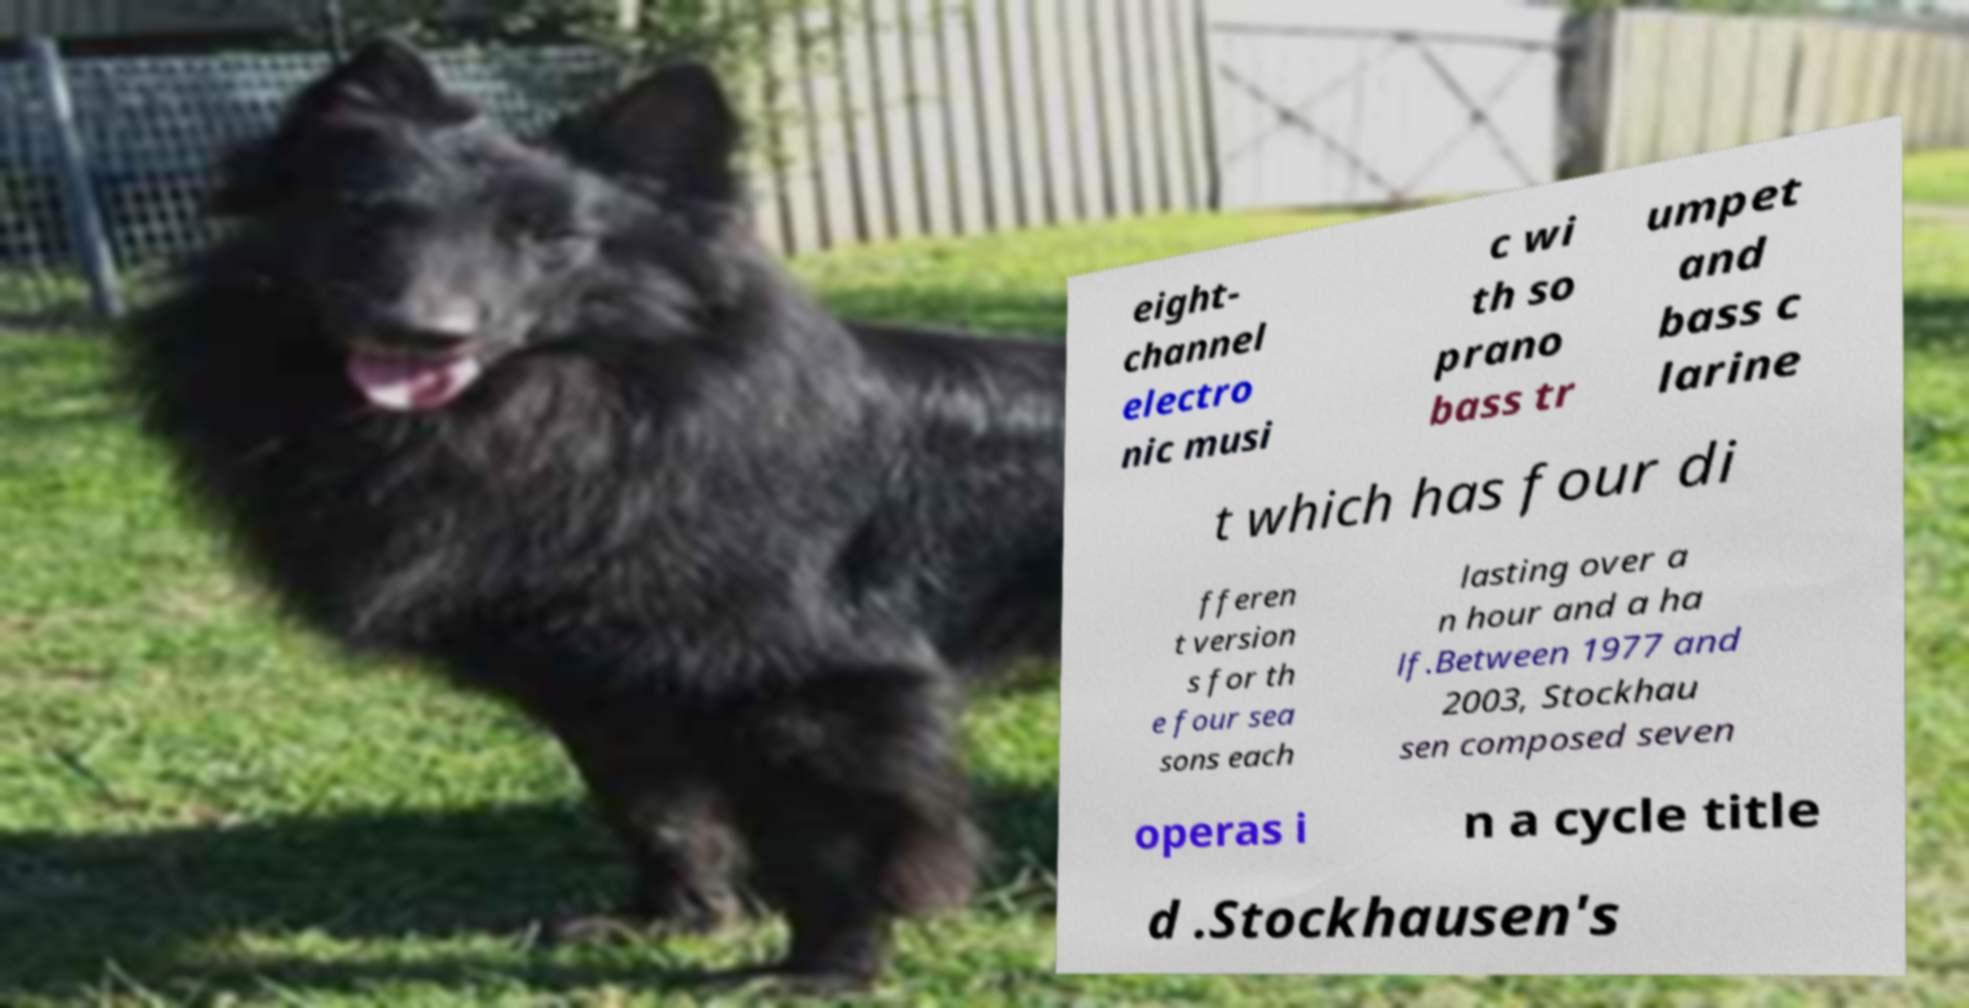Could you extract and type out the text from this image? eight- channel electro nic musi c wi th so prano bass tr umpet and bass c larine t which has four di fferen t version s for th e four sea sons each lasting over a n hour and a ha lf.Between 1977 and 2003, Stockhau sen composed seven operas i n a cycle title d .Stockhausen's 